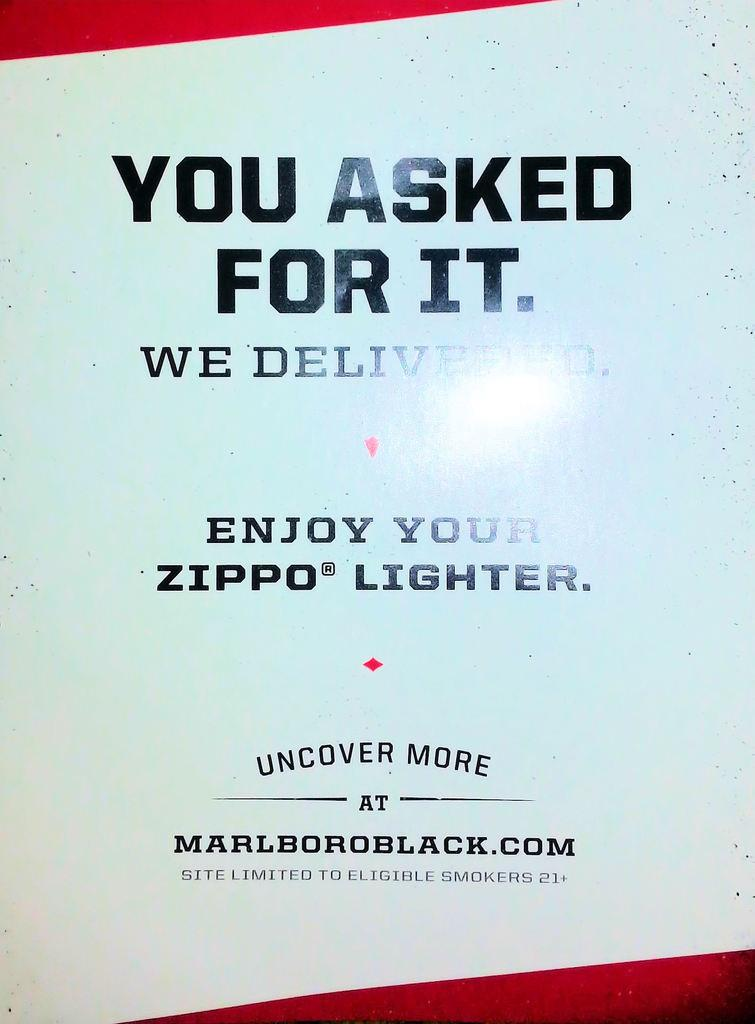Provide a one-sentence caption for the provided image. An ad for Marlboro also includes a Zippo lighter. 